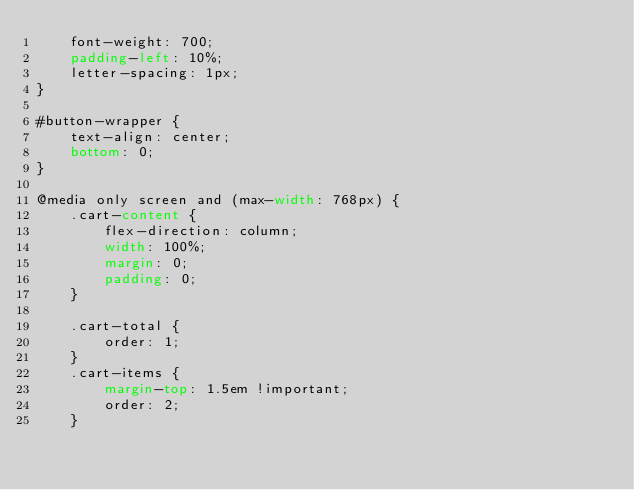Convert code to text. <code><loc_0><loc_0><loc_500><loc_500><_CSS_>    font-weight: 700;
    padding-left: 10%;
    letter-spacing: 1px;
}

#button-wrapper {
    text-align: center;
    bottom: 0;
}

@media only screen and (max-width: 768px) {
    .cart-content {
        flex-direction: column;
        width: 100%;
        margin: 0;
        padding: 0;
    }

    .cart-total {
        order: 1;
    }
    .cart-items {
        margin-top: 1.5em !important;
        order: 2;
    }
</code> 